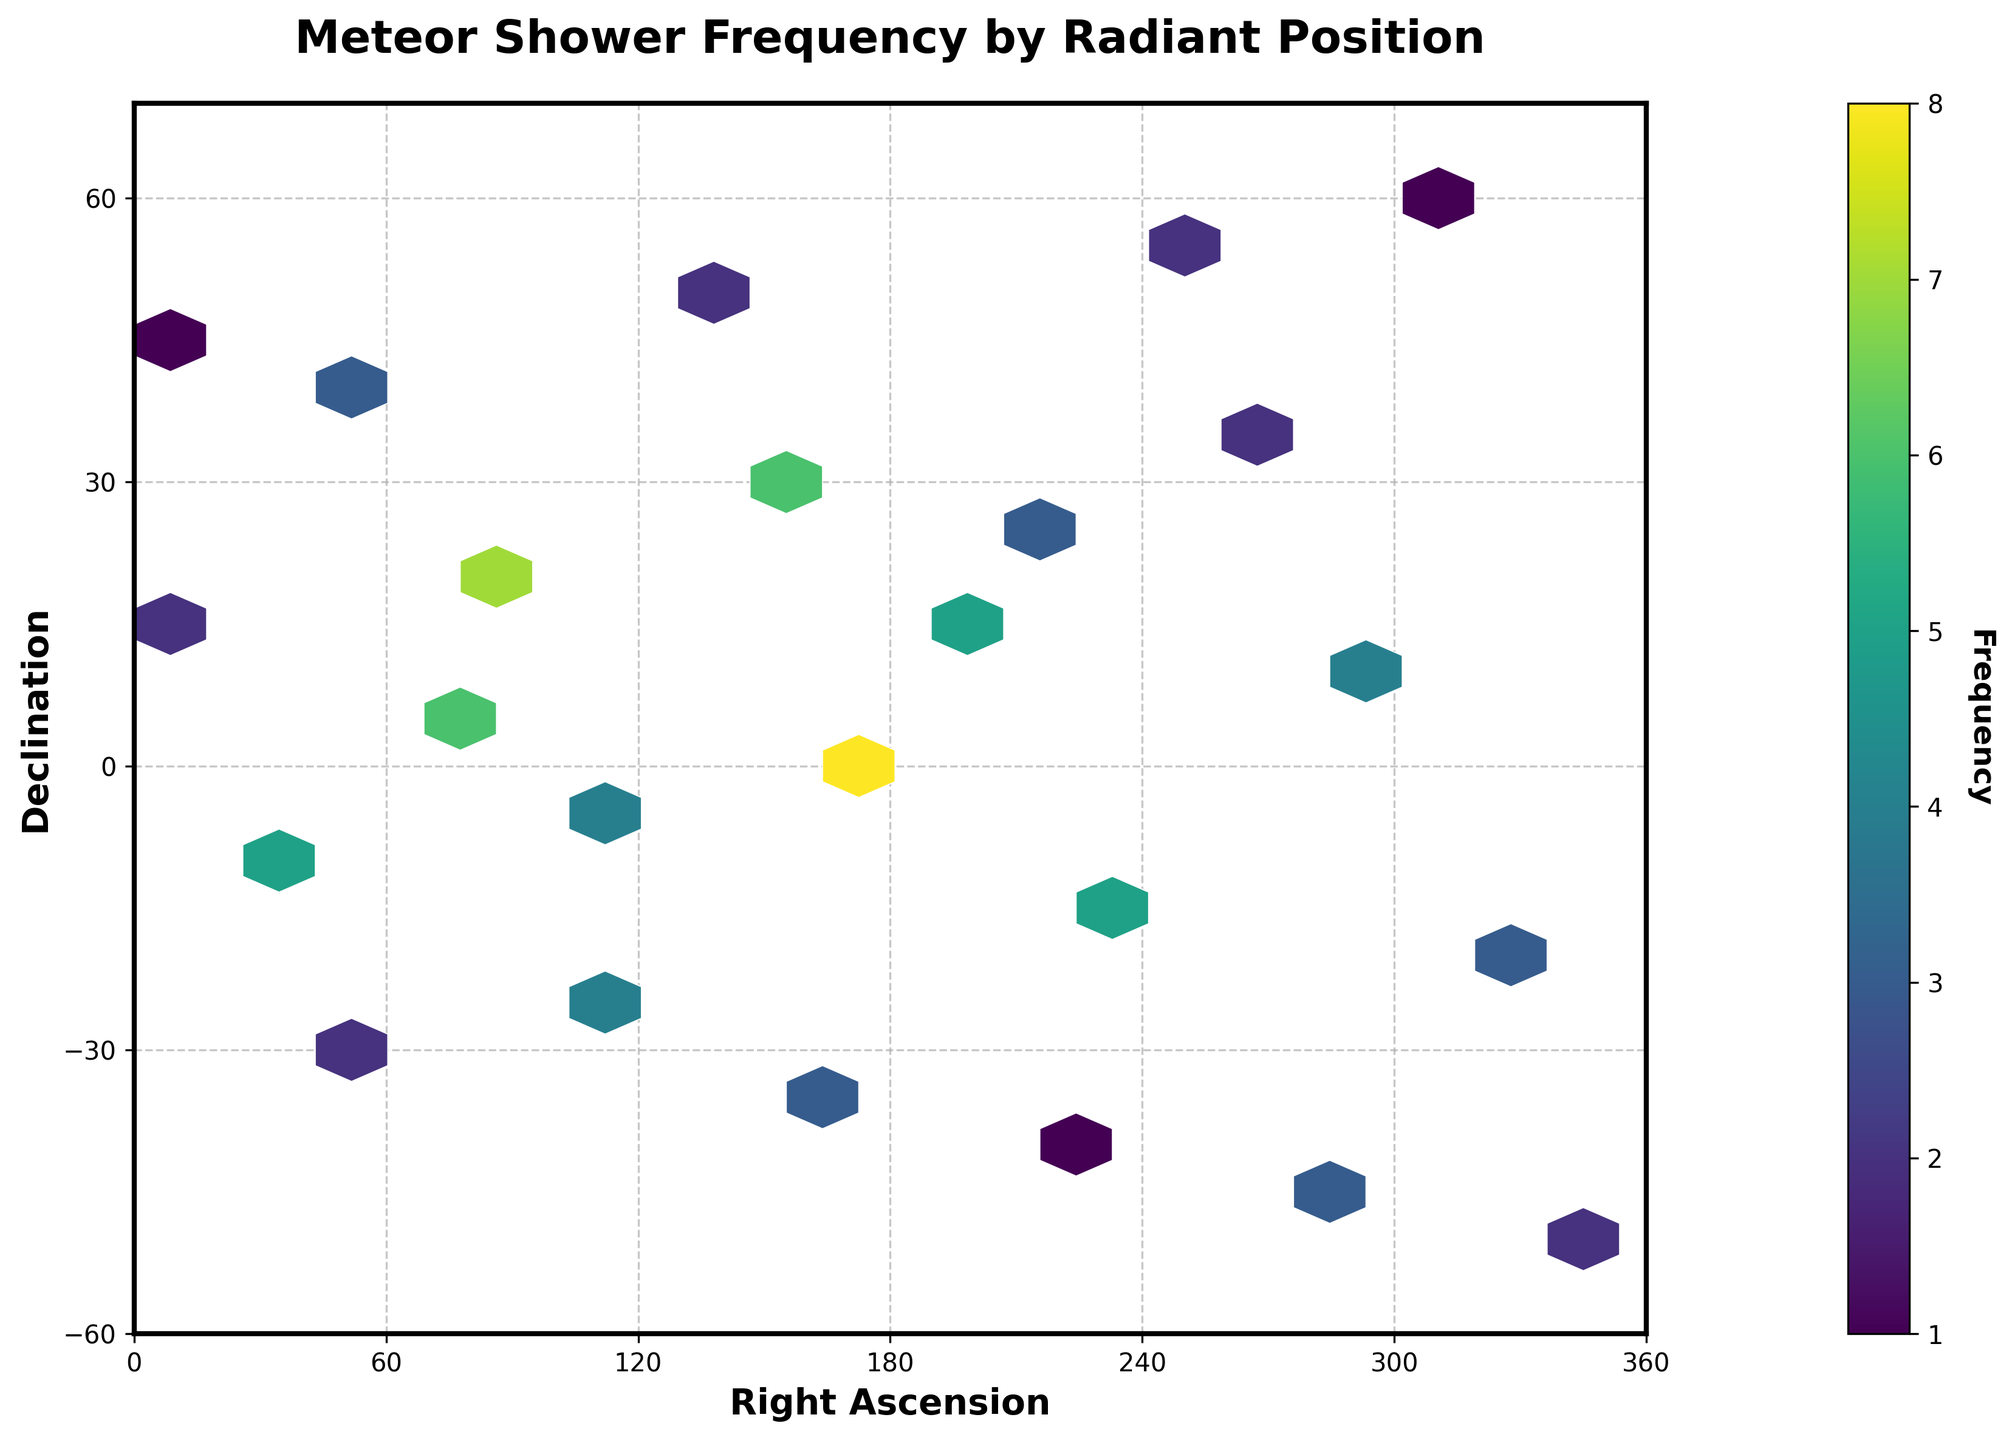What is the title of this figure? The title is usually placed at the top of the figure, prominently displayed to indicate the subject of the plot.
Answer: Meteor Shower Frequency by Radiant Position What does the color intensity represent in the hexbin plot? The color intensity, usually represented by the color bar on the side, indicates the frequency values of meteor showers. The darker or more intense the color, the higher the frequency.
Answer: Frequency What are the axis labels in this figure? The axis labels provide context to the plotted data. They mark what each axis represents. In this case, the x-axis and y-axis are labeled with descriptive names.
Answer: Right Ascension (x-axis) and Declination (y-axis) Within what range do the right ascension values fall? The x-axis (Right Ascension) has specific tick marks that indicate the range of values displayed. Observing these marks will clarify the boundaries.
Answer: 0 to 360 How frequently were meteor showers observed at a declination of 0°? Locate the y-coordinate for 0° declination and observe the hexbin cells along this line to determine their color intensity as described by the color bar.
Answer: 8 times Which radiant position had the highest frequency of meteor showers? By examining the hexbin plot and finding the darkest or most intense cell, you can locate the point with the highest frequency.
Answer: Right Ascension: 180°, Declination: 0° How many declination values are north of the celestial equator (>=0°) in the plot? Count the number of data points whose declination values are 0° or above by analyzing the distribution of hexbin cells in the upper half of the plot.
Answer: 13 What is the frequency difference between meteor showers at Right Ascension 90° and 210°? Find the frequencies at these specific right ascensions and subtract one from the other.
Answer: 4 (7 at 90° and 3 at 210°) Do more meteor showers occur at declinations north or south of the celestial equator? Compare the quantity and intensity of hexbin cells in the upper half (>0°) versus the lower half (<0°) of the plot.
Answer: South Is there a trend in meteor shower frequency as a function of declination? Observe if there is a discernible pattern or gradient from the top to the bottom or across the plot, signifying an increase or decrease.
Answer: Yes, more frequent in the central belt (near the equator) 